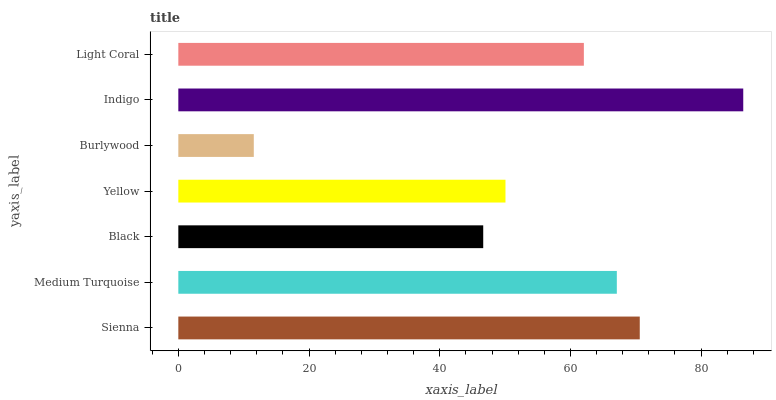Is Burlywood the minimum?
Answer yes or no. Yes. Is Indigo the maximum?
Answer yes or no. Yes. Is Medium Turquoise the minimum?
Answer yes or no. No. Is Medium Turquoise the maximum?
Answer yes or no. No. Is Sienna greater than Medium Turquoise?
Answer yes or no. Yes. Is Medium Turquoise less than Sienna?
Answer yes or no. Yes. Is Medium Turquoise greater than Sienna?
Answer yes or no. No. Is Sienna less than Medium Turquoise?
Answer yes or no. No. Is Light Coral the high median?
Answer yes or no. Yes. Is Light Coral the low median?
Answer yes or no. Yes. Is Black the high median?
Answer yes or no. No. Is Burlywood the low median?
Answer yes or no. No. 